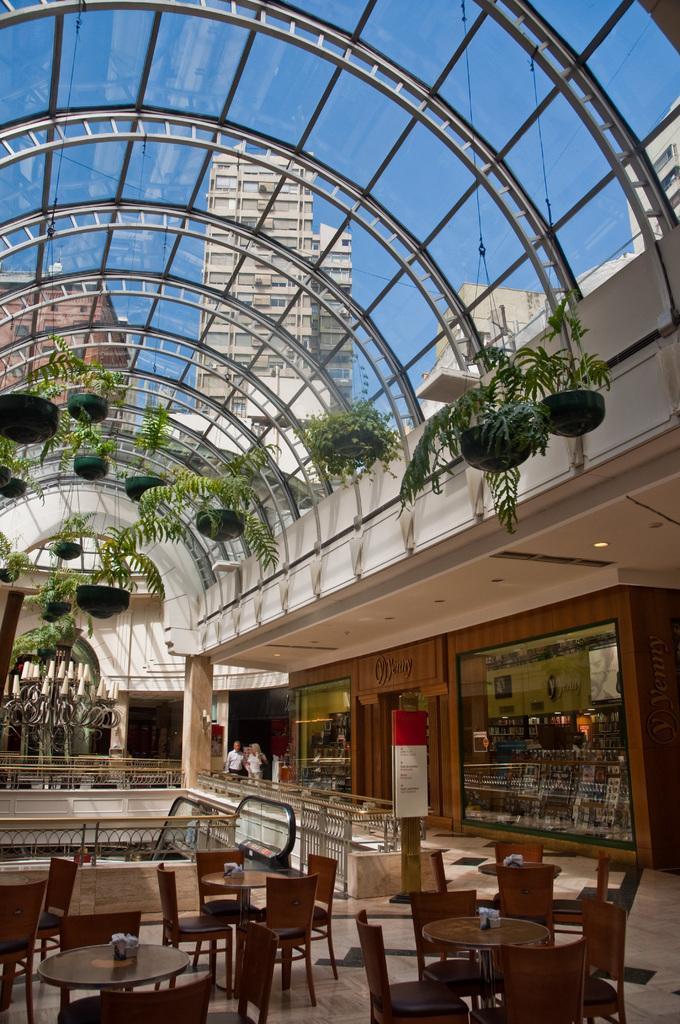Could you give a brief overview of what you see in this image? This image is taken inside of a building where we can see tables, chairs, railing, a shop, boards, plants hanging to the glass ceiling. Through the glass on the top, we can see buildings, and the sky. 